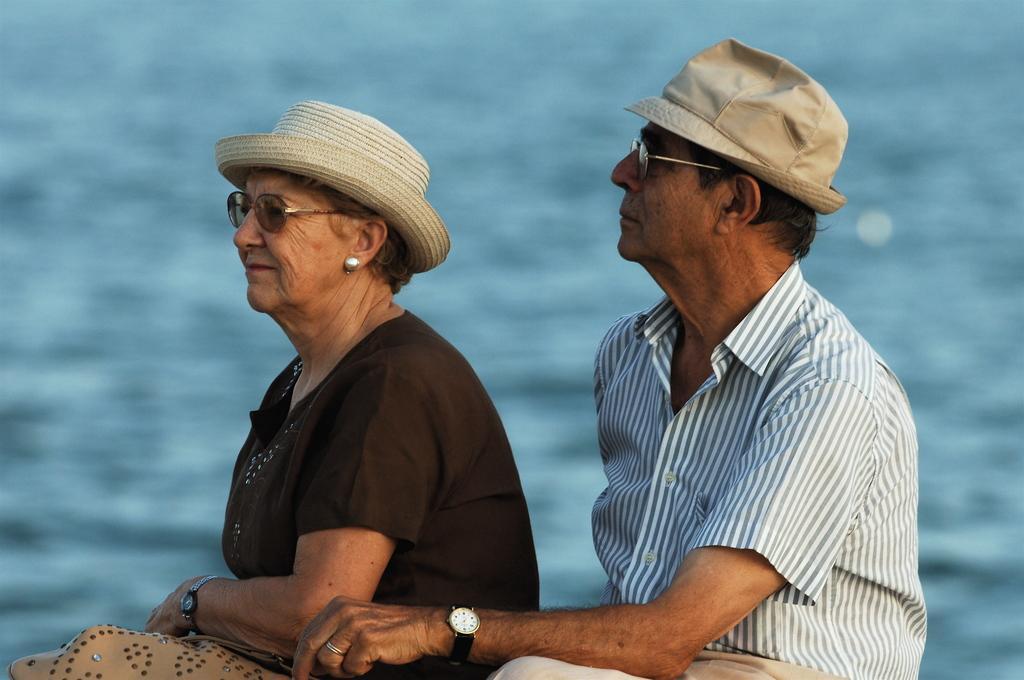How would you summarize this image in a sentence or two? In this image, we can see two people sitting and the background is blurred. 